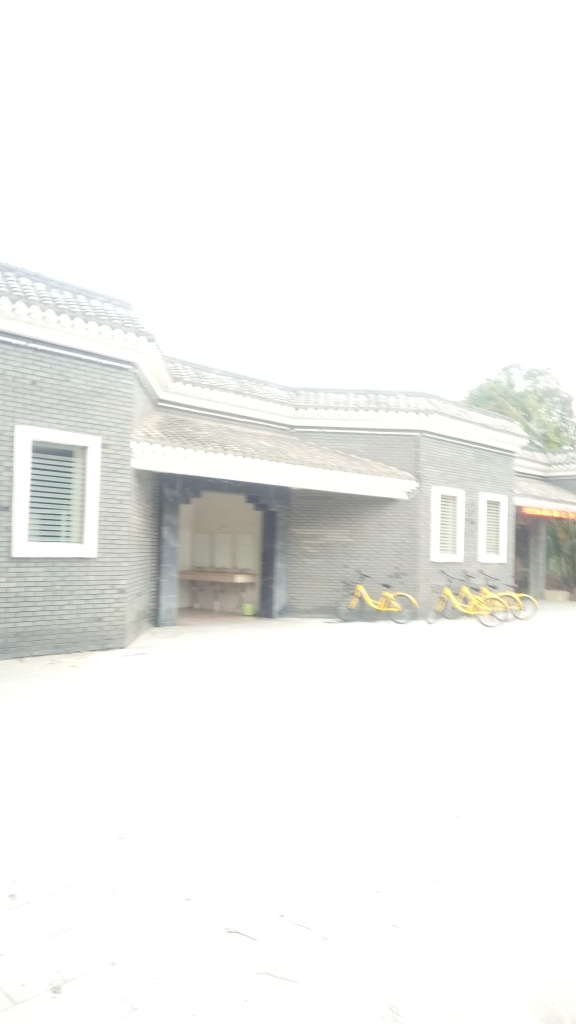Can you infer the time of day or weather conditions when this photo was taken? While the excessive brightness makes it difficult to determine the exact conditions, the diffuse light and lack of harsh shadows suggest the photo may have been taken on an overcast day or during a time when the sun is not at its peak, possibly morning or late afternoon. 